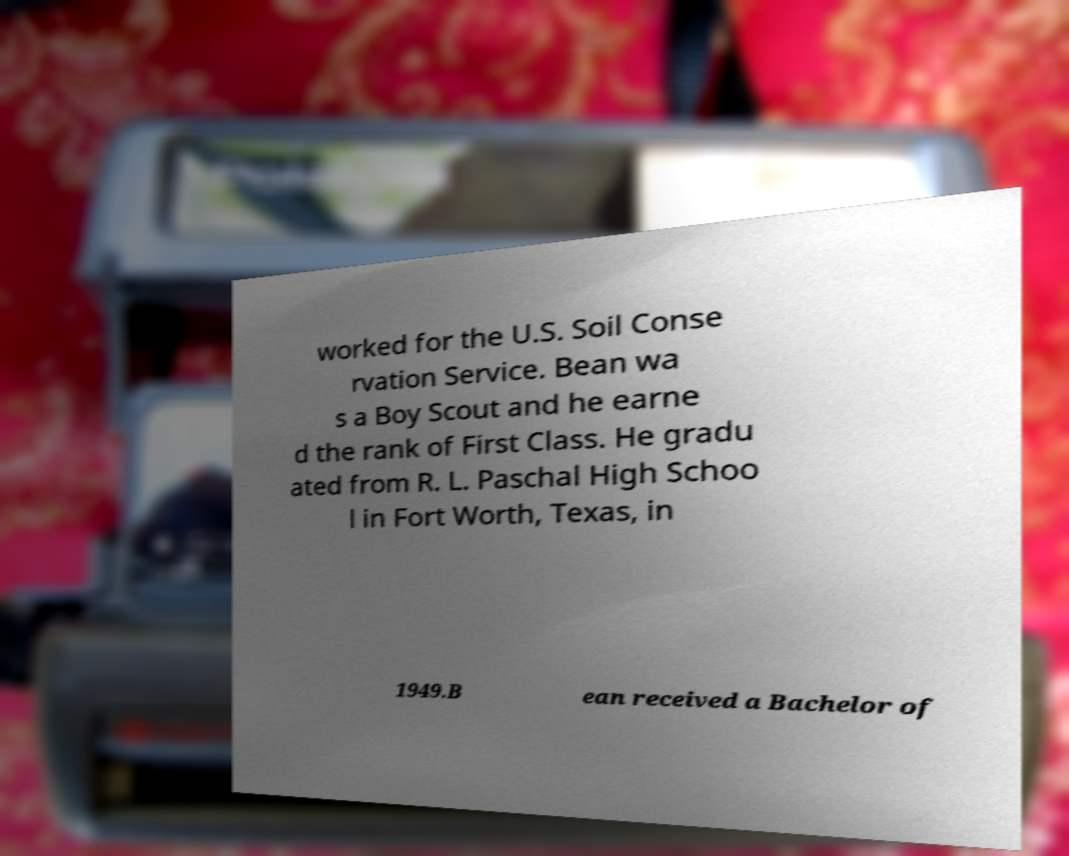Please read and relay the text visible in this image. What does it say? worked for the U.S. Soil Conse rvation Service. Bean wa s a Boy Scout and he earne d the rank of First Class. He gradu ated from R. L. Paschal High Schoo l in Fort Worth, Texas, in 1949.B ean received a Bachelor of 